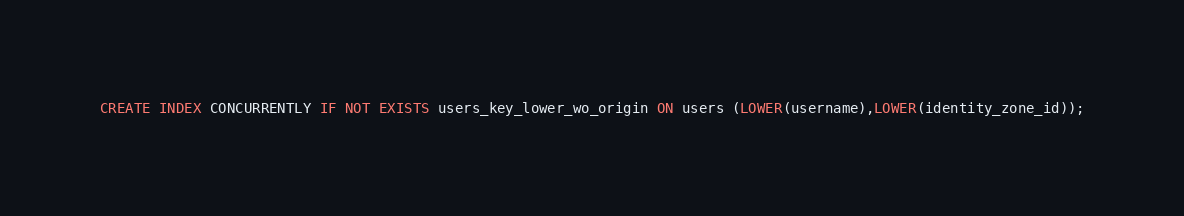Convert code to text. <code><loc_0><loc_0><loc_500><loc_500><_SQL_>CREATE INDEX CONCURRENTLY IF NOT EXISTS users_key_lower_wo_origin ON users (LOWER(username),LOWER(identity_zone_id));
</code> 